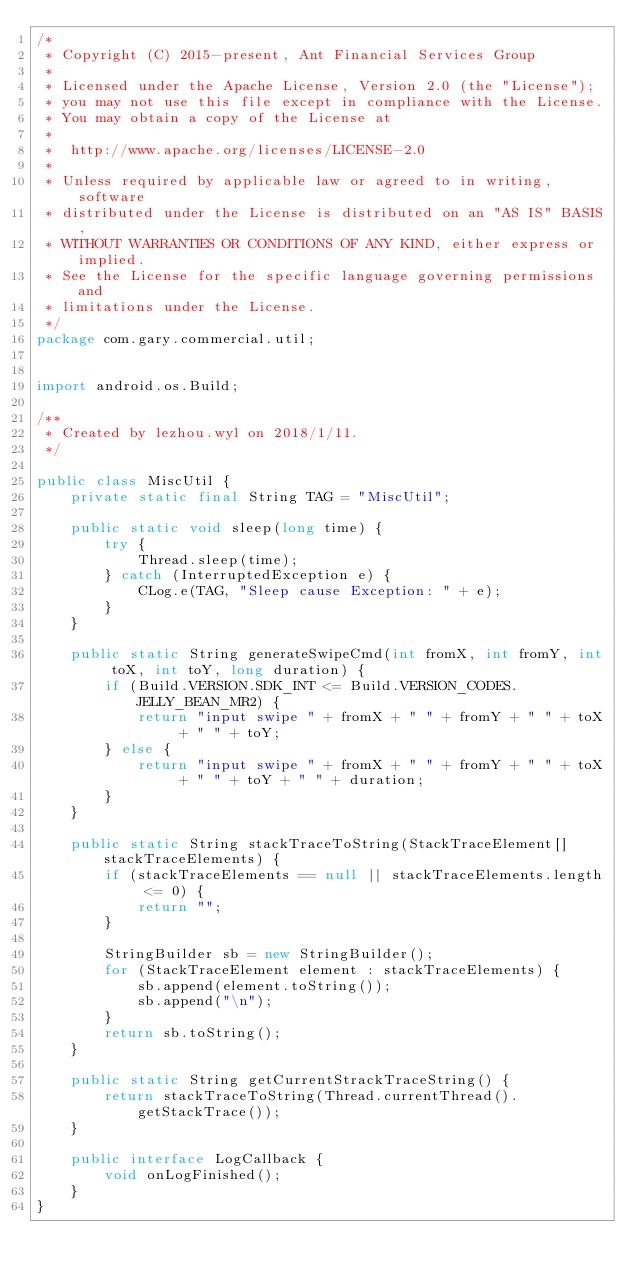Convert code to text. <code><loc_0><loc_0><loc_500><loc_500><_Java_>/*
 * Copyright (C) 2015-present, Ant Financial Services Group
 *
 * Licensed under the Apache License, Version 2.0 (the "License");
 * you may not use this file except in compliance with the License.
 * You may obtain a copy of the License at
 *
 * 	http://www.apache.org/licenses/LICENSE-2.0
 *
 * Unless required by applicable law or agreed to in writing, software
 * distributed under the License is distributed on an "AS IS" BASIS,
 * WITHOUT WARRANTIES OR CONDITIONS OF ANY KIND, either express or implied.
 * See the License for the specific language governing permissions and
 * limitations under the License.
 */
package com.gary.commercial.util;


import android.os.Build;

/**
 * Created by lezhou.wyl on 2018/1/11.
 */

public class MiscUtil {
    private static final String TAG = "MiscUtil";

    public static void sleep(long time) {
        try {
            Thread.sleep(time);
        } catch (InterruptedException e) {
            CLog.e(TAG, "Sleep cause Exception: " + e);
        }
    }

    public static String generateSwipeCmd(int fromX, int fromY, int toX, int toY, long duration) {
        if (Build.VERSION.SDK_INT <= Build.VERSION_CODES.JELLY_BEAN_MR2) {
            return "input swipe " + fromX + " " + fromY + " " + toX + " " + toY;
        } else {
            return "input swipe " + fromX + " " + fromY + " " + toX + " " + toY + " " + duration;
        }
    }

    public static String stackTraceToString(StackTraceElement[] stackTraceElements) {
        if (stackTraceElements == null || stackTraceElements.length <= 0) {
            return "";
        }

        StringBuilder sb = new StringBuilder();
        for (StackTraceElement element : stackTraceElements) {
            sb.append(element.toString());
            sb.append("\n");
        }
        return sb.toString();
    }

    public static String getCurrentStrackTraceString() {
        return stackTraceToString(Thread.currentThread().getStackTrace());
    }

    public interface LogCallback {
        void onLogFinished();
    }
}
</code> 